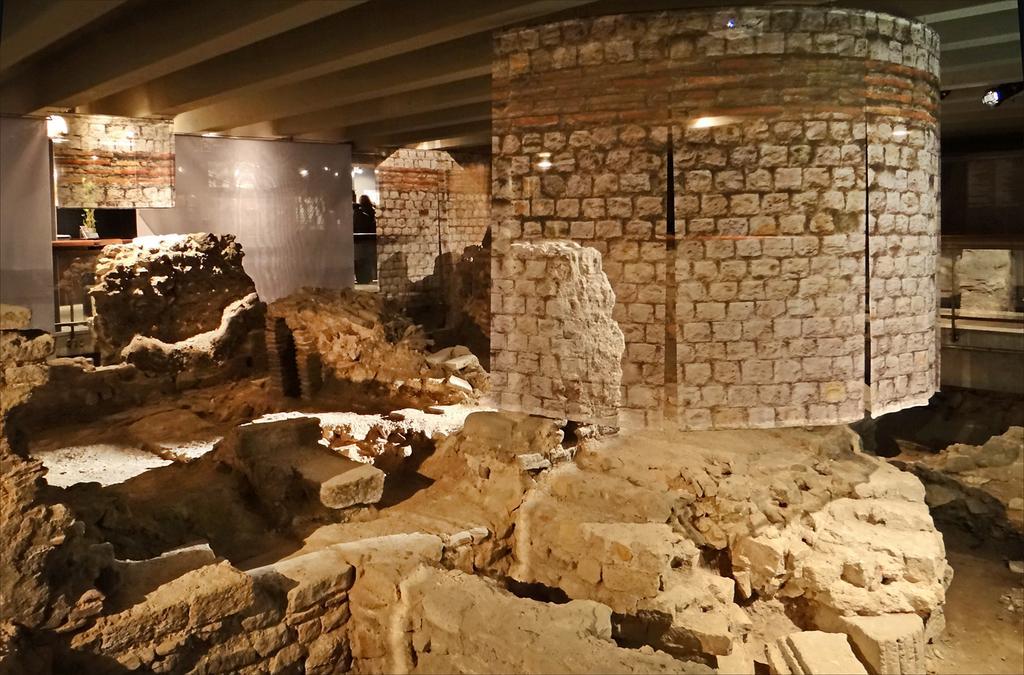Please provide a concise description of this image. We can see collapsed walls and there are brick wall banners and boards. In the background there are clothes, lights, objects and few persons. 